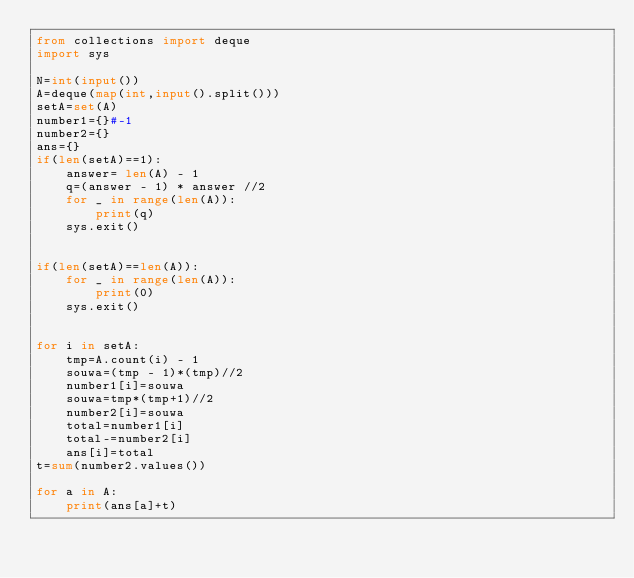<code> <loc_0><loc_0><loc_500><loc_500><_Python_>from collections import deque
import sys

N=int(input())
A=deque(map(int,input().split()))
setA=set(A)
number1={}#-1
number2={}
ans={}
if(len(setA)==1):
    answer= len(A) - 1
    q=(answer - 1) * answer //2
    for _ in range(len(A)):
        print(q)
    sys.exit()


if(len(setA)==len(A)):
    for _ in range(len(A)):
        print(0)
    sys.exit()


for i in setA:
    tmp=A.count(i) - 1
    souwa=(tmp - 1)*(tmp)//2
    number1[i]=souwa
    souwa=tmp*(tmp+1)//2
    number2[i]=souwa
    total=number1[i]
    total-=number2[i]
    ans[i]=total
t=sum(number2.values())

for a in A:
    print(ans[a]+t)


</code> 